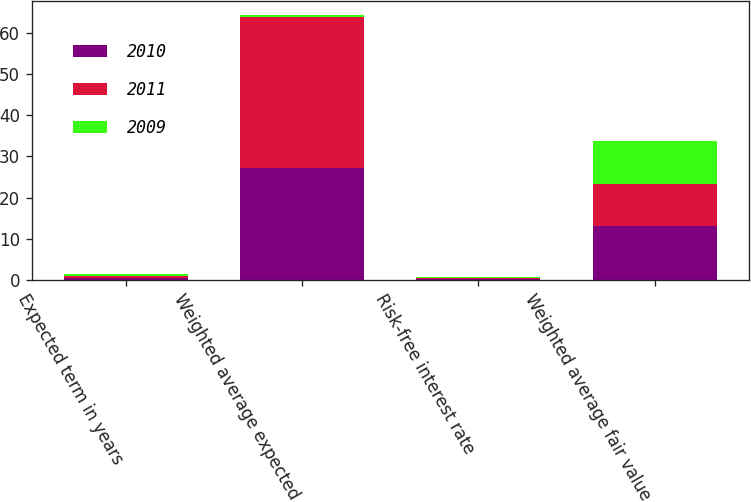Convert chart. <chart><loc_0><loc_0><loc_500><loc_500><stacked_bar_chart><ecel><fcel>Expected term in years<fcel>Weighted average expected<fcel>Risk-free interest rate<fcel>Weighted average fair value<nl><fcel>2010<fcel>0.5<fcel>27.3<fcel>0.15<fcel>13.02<nl><fcel>2011<fcel>0.5<fcel>36.7<fcel>0.22<fcel>10.22<nl><fcel>2009<fcel>0.5<fcel>0.5<fcel>0.3<fcel>10.53<nl></chart> 